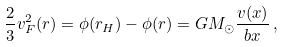<formula> <loc_0><loc_0><loc_500><loc_500>\frac { 2 } { 3 } v _ { F } ^ { 2 } ( r ) = \phi ( r _ { H } ) - \phi ( r ) = G M _ { \odot } \frac { v ( x ) } { b x } \, ,</formula> 